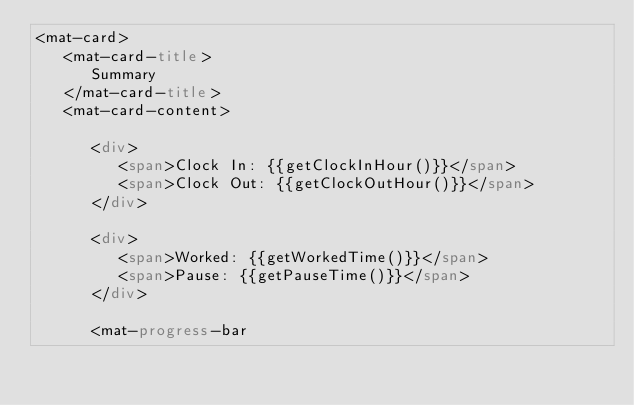<code> <loc_0><loc_0><loc_500><loc_500><_HTML_><mat-card>
   <mat-card-title>
      Summary
   </mat-card-title>
   <mat-card-content>

      <div>
         <span>Clock In: {{getClockInHour()}}</span>
         <span>Clock Out: {{getClockOutHour()}}</span>
      </div>

      <div>
         <span>Worked: {{getWorkedTime()}}</span>
         <span>Pause: {{getPauseTime()}}</span>
      </div>

      <mat-progress-bar</code> 